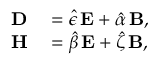<formula> <loc_0><loc_0><loc_500><loc_500>\begin{array} { r l } { D } & = \hat { \epsilon } \, E + \hat { \alpha } \, B , } \\ { H } & = \hat { \beta } \, E + \hat { \zeta } \, B , } \end{array}</formula> 